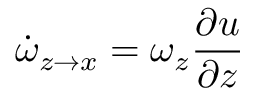<formula> <loc_0><loc_0><loc_500><loc_500>\dot { \omega } _ { z \rightarrow x } = \omega _ { z } \frac { \partial u } { \partial z }</formula> 